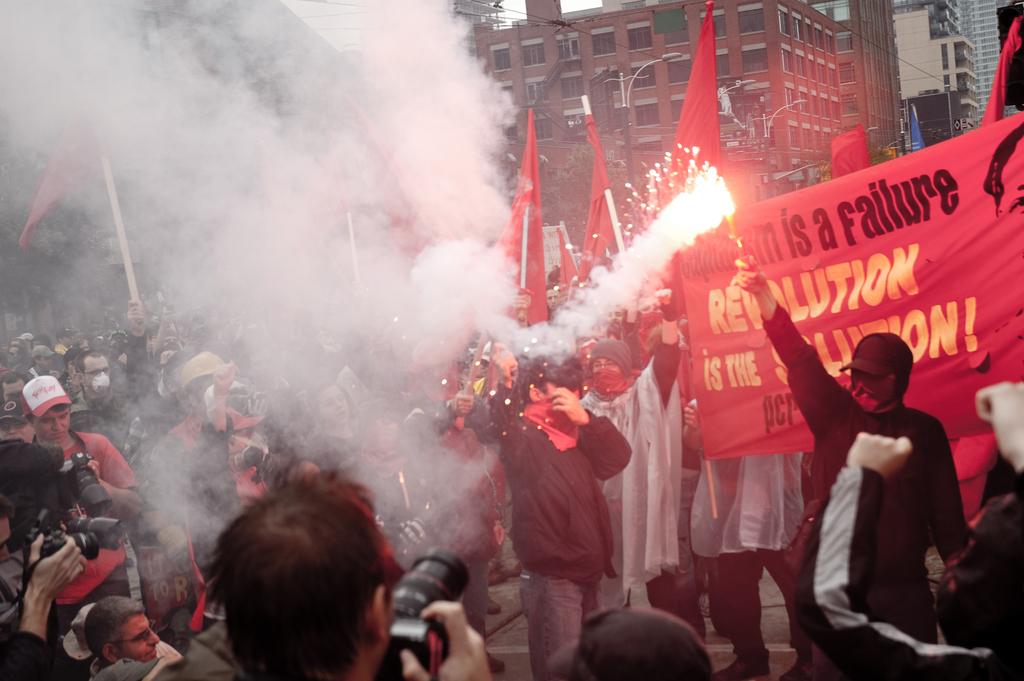What is a failure according to the banner?
Your response must be concise. Capitalism. What word is in yellow on the banners?
Your answer should be compact. Revolution. 